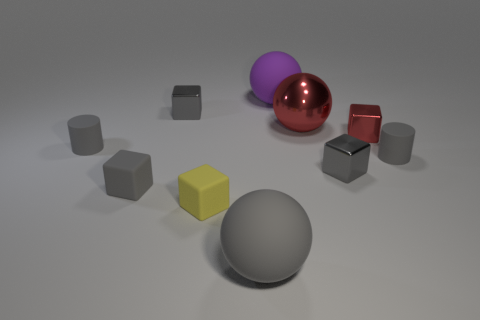The thing that is the same color as the shiny sphere is what size?
Keep it short and to the point. Small. The tiny metallic thing that is the same color as the metal ball is what shape?
Offer a very short reply. Cube. How many large objects are either blue shiny cylinders or red metal spheres?
Your answer should be very brief. 1. The other small rubber object that is the same shape as the tiny yellow rubber object is what color?
Keep it short and to the point. Gray. Is the size of the red metal sphere the same as the purple object?
Keep it short and to the point. Yes. What number of objects are either metal spheres or tiny gray metallic cubes that are on the left side of the red shiny ball?
Offer a very short reply. 2. The big rubber thing in front of the rubber cylinder to the left of the large purple rubber thing is what color?
Your answer should be compact. Gray. Do the small cylinder on the left side of the gray sphere and the metal sphere have the same color?
Keep it short and to the point. No. There is a purple ball behind the tiny gray rubber block; what is it made of?
Offer a very short reply. Rubber. The red block is what size?
Provide a succinct answer. Small. 